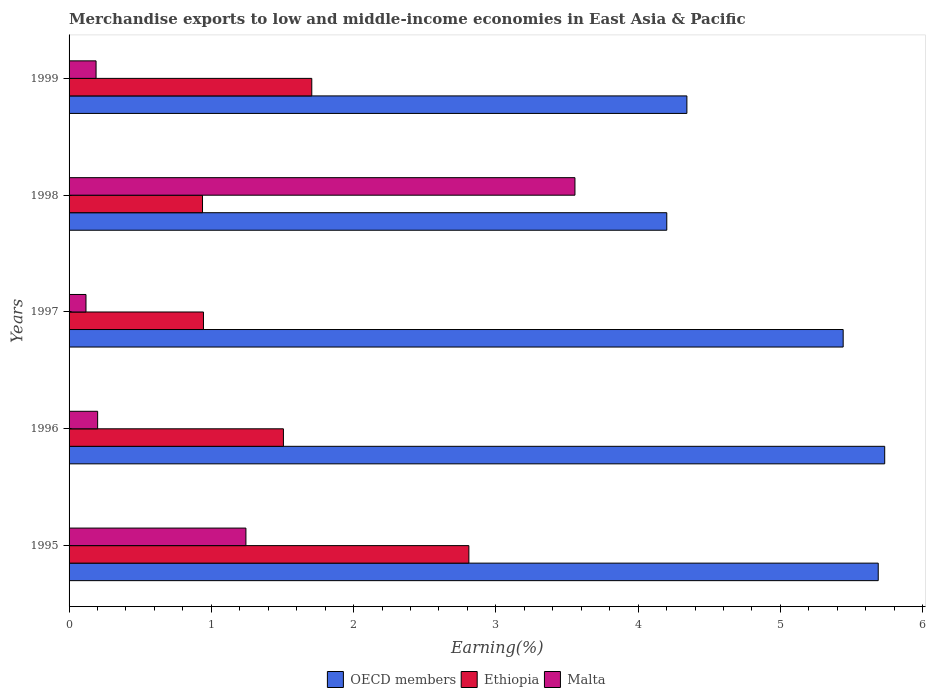How many different coloured bars are there?
Your answer should be compact. 3. How many groups of bars are there?
Offer a very short reply. 5. Are the number of bars per tick equal to the number of legend labels?
Offer a very short reply. Yes. How many bars are there on the 5th tick from the top?
Your answer should be compact. 3. How many bars are there on the 5th tick from the bottom?
Provide a succinct answer. 3. What is the label of the 4th group of bars from the top?
Your response must be concise. 1996. In how many cases, is the number of bars for a given year not equal to the number of legend labels?
Give a very brief answer. 0. What is the percentage of amount earned from merchandise exports in OECD members in 1998?
Your answer should be very brief. 4.2. Across all years, what is the maximum percentage of amount earned from merchandise exports in Ethiopia?
Offer a very short reply. 2.81. Across all years, what is the minimum percentage of amount earned from merchandise exports in Malta?
Your answer should be very brief. 0.12. In which year was the percentage of amount earned from merchandise exports in Malta maximum?
Offer a very short reply. 1998. In which year was the percentage of amount earned from merchandise exports in Ethiopia minimum?
Offer a terse response. 1998. What is the total percentage of amount earned from merchandise exports in Malta in the graph?
Give a very brief answer. 5.31. What is the difference between the percentage of amount earned from merchandise exports in Malta in 1995 and that in 1998?
Ensure brevity in your answer.  -2.31. What is the difference between the percentage of amount earned from merchandise exports in Ethiopia in 1998 and the percentage of amount earned from merchandise exports in OECD members in 1997?
Your response must be concise. -4.5. What is the average percentage of amount earned from merchandise exports in Malta per year?
Ensure brevity in your answer.  1.06. In the year 1996, what is the difference between the percentage of amount earned from merchandise exports in Ethiopia and percentage of amount earned from merchandise exports in Malta?
Your answer should be compact. 1.31. What is the ratio of the percentage of amount earned from merchandise exports in Malta in 1995 to that in 1998?
Provide a short and direct response. 0.35. Is the difference between the percentage of amount earned from merchandise exports in Ethiopia in 1995 and 1998 greater than the difference between the percentage of amount earned from merchandise exports in Malta in 1995 and 1998?
Your answer should be compact. Yes. What is the difference between the highest and the second highest percentage of amount earned from merchandise exports in Ethiopia?
Ensure brevity in your answer.  1.1. What is the difference between the highest and the lowest percentage of amount earned from merchandise exports in Ethiopia?
Ensure brevity in your answer.  1.87. In how many years, is the percentage of amount earned from merchandise exports in Ethiopia greater than the average percentage of amount earned from merchandise exports in Ethiopia taken over all years?
Your answer should be compact. 2. Is the sum of the percentage of amount earned from merchandise exports in Ethiopia in 1996 and 1999 greater than the maximum percentage of amount earned from merchandise exports in Malta across all years?
Provide a succinct answer. No. What does the 1st bar from the top in 1998 represents?
Keep it short and to the point. Malta. Is it the case that in every year, the sum of the percentage of amount earned from merchandise exports in Ethiopia and percentage of amount earned from merchandise exports in Malta is greater than the percentage of amount earned from merchandise exports in OECD members?
Offer a very short reply. No. Are all the bars in the graph horizontal?
Provide a succinct answer. Yes. How many years are there in the graph?
Make the answer very short. 5. Does the graph contain any zero values?
Provide a short and direct response. No. Where does the legend appear in the graph?
Offer a terse response. Bottom center. How many legend labels are there?
Offer a terse response. 3. What is the title of the graph?
Make the answer very short. Merchandise exports to low and middle-income economies in East Asia & Pacific. What is the label or title of the X-axis?
Your response must be concise. Earning(%). What is the Earning(%) of OECD members in 1995?
Provide a short and direct response. 5.69. What is the Earning(%) of Ethiopia in 1995?
Provide a succinct answer. 2.81. What is the Earning(%) in Malta in 1995?
Keep it short and to the point. 1.24. What is the Earning(%) in OECD members in 1996?
Provide a short and direct response. 5.73. What is the Earning(%) of Ethiopia in 1996?
Offer a very short reply. 1.51. What is the Earning(%) of Malta in 1996?
Keep it short and to the point. 0.2. What is the Earning(%) in OECD members in 1997?
Offer a terse response. 5.44. What is the Earning(%) of Ethiopia in 1997?
Your answer should be very brief. 0.94. What is the Earning(%) of Malta in 1997?
Give a very brief answer. 0.12. What is the Earning(%) of OECD members in 1998?
Make the answer very short. 4.2. What is the Earning(%) in Ethiopia in 1998?
Offer a very short reply. 0.94. What is the Earning(%) of Malta in 1998?
Provide a succinct answer. 3.56. What is the Earning(%) in OECD members in 1999?
Offer a terse response. 4.34. What is the Earning(%) in Ethiopia in 1999?
Make the answer very short. 1.71. What is the Earning(%) in Malta in 1999?
Offer a very short reply. 0.19. Across all years, what is the maximum Earning(%) of OECD members?
Your answer should be very brief. 5.73. Across all years, what is the maximum Earning(%) in Ethiopia?
Your answer should be very brief. 2.81. Across all years, what is the maximum Earning(%) of Malta?
Make the answer very short. 3.56. Across all years, what is the minimum Earning(%) in OECD members?
Offer a very short reply. 4.2. Across all years, what is the minimum Earning(%) of Ethiopia?
Your response must be concise. 0.94. Across all years, what is the minimum Earning(%) of Malta?
Your response must be concise. 0.12. What is the total Earning(%) in OECD members in the graph?
Your answer should be very brief. 25.41. What is the total Earning(%) of Ethiopia in the graph?
Offer a terse response. 7.91. What is the total Earning(%) in Malta in the graph?
Offer a terse response. 5.31. What is the difference between the Earning(%) of OECD members in 1995 and that in 1996?
Keep it short and to the point. -0.05. What is the difference between the Earning(%) in Ethiopia in 1995 and that in 1996?
Give a very brief answer. 1.3. What is the difference between the Earning(%) of Malta in 1995 and that in 1996?
Ensure brevity in your answer.  1.04. What is the difference between the Earning(%) of OECD members in 1995 and that in 1997?
Offer a very short reply. 0.25. What is the difference between the Earning(%) of Ethiopia in 1995 and that in 1997?
Provide a succinct answer. 1.87. What is the difference between the Earning(%) of Malta in 1995 and that in 1997?
Your answer should be compact. 1.12. What is the difference between the Earning(%) in OECD members in 1995 and that in 1998?
Your answer should be very brief. 1.49. What is the difference between the Earning(%) in Ethiopia in 1995 and that in 1998?
Your answer should be compact. 1.87. What is the difference between the Earning(%) of Malta in 1995 and that in 1998?
Make the answer very short. -2.31. What is the difference between the Earning(%) of OECD members in 1995 and that in 1999?
Make the answer very short. 1.34. What is the difference between the Earning(%) in Ethiopia in 1995 and that in 1999?
Your answer should be very brief. 1.1. What is the difference between the Earning(%) of Malta in 1995 and that in 1999?
Your answer should be very brief. 1.05. What is the difference between the Earning(%) of OECD members in 1996 and that in 1997?
Offer a very short reply. 0.29. What is the difference between the Earning(%) in Ethiopia in 1996 and that in 1997?
Your answer should be very brief. 0.56. What is the difference between the Earning(%) in Malta in 1996 and that in 1997?
Provide a short and direct response. 0.08. What is the difference between the Earning(%) of OECD members in 1996 and that in 1998?
Give a very brief answer. 1.53. What is the difference between the Earning(%) of Ethiopia in 1996 and that in 1998?
Ensure brevity in your answer.  0.57. What is the difference between the Earning(%) in Malta in 1996 and that in 1998?
Give a very brief answer. -3.36. What is the difference between the Earning(%) of OECD members in 1996 and that in 1999?
Make the answer very short. 1.39. What is the difference between the Earning(%) in Ethiopia in 1996 and that in 1999?
Give a very brief answer. -0.2. What is the difference between the Earning(%) of Malta in 1996 and that in 1999?
Make the answer very short. 0.01. What is the difference between the Earning(%) in OECD members in 1997 and that in 1998?
Provide a short and direct response. 1.24. What is the difference between the Earning(%) in Ethiopia in 1997 and that in 1998?
Your answer should be compact. 0.01. What is the difference between the Earning(%) of Malta in 1997 and that in 1998?
Make the answer very short. -3.44. What is the difference between the Earning(%) in OECD members in 1997 and that in 1999?
Ensure brevity in your answer.  1.1. What is the difference between the Earning(%) of Ethiopia in 1997 and that in 1999?
Ensure brevity in your answer.  -0.76. What is the difference between the Earning(%) of Malta in 1997 and that in 1999?
Provide a short and direct response. -0.07. What is the difference between the Earning(%) in OECD members in 1998 and that in 1999?
Your response must be concise. -0.14. What is the difference between the Earning(%) of Ethiopia in 1998 and that in 1999?
Ensure brevity in your answer.  -0.77. What is the difference between the Earning(%) in Malta in 1998 and that in 1999?
Make the answer very short. 3.37. What is the difference between the Earning(%) in OECD members in 1995 and the Earning(%) in Ethiopia in 1996?
Your answer should be compact. 4.18. What is the difference between the Earning(%) of OECD members in 1995 and the Earning(%) of Malta in 1996?
Keep it short and to the point. 5.49. What is the difference between the Earning(%) of Ethiopia in 1995 and the Earning(%) of Malta in 1996?
Provide a succinct answer. 2.61. What is the difference between the Earning(%) in OECD members in 1995 and the Earning(%) in Ethiopia in 1997?
Provide a succinct answer. 4.74. What is the difference between the Earning(%) in OECD members in 1995 and the Earning(%) in Malta in 1997?
Your answer should be very brief. 5.57. What is the difference between the Earning(%) in Ethiopia in 1995 and the Earning(%) in Malta in 1997?
Your answer should be compact. 2.69. What is the difference between the Earning(%) in OECD members in 1995 and the Earning(%) in Ethiopia in 1998?
Offer a very short reply. 4.75. What is the difference between the Earning(%) of OECD members in 1995 and the Earning(%) of Malta in 1998?
Give a very brief answer. 2.13. What is the difference between the Earning(%) in Ethiopia in 1995 and the Earning(%) in Malta in 1998?
Provide a succinct answer. -0.75. What is the difference between the Earning(%) in OECD members in 1995 and the Earning(%) in Ethiopia in 1999?
Provide a short and direct response. 3.98. What is the difference between the Earning(%) of OECD members in 1995 and the Earning(%) of Malta in 1999?
Give a very brief answer. 5.5. What is the difference between the Earning(%) of Ethiopia in 1995 and the Earning(%) of Malta in 1999?
Your response must be concise. 2.62. What is the difference between the Earning(%) in OECD members in 1996 and the Earning(%) in Ethiopia in 1997?
Your answer should be compact. 4.79. What is the difference between the Earning(%) of OECD members in 1996 and the Earning(%) of Malta in 1997?
Provide a succinct answer. 5.61. What is the difference between the Earning(%) of Ethiopia in 1996 and the Earning(%) of Malta in 1997?
Your answer should be compact. 1.39. What is the difference between the Earning(%) in OECD members in 1996 and the Earning(%) in Ethiopia in 1998?
Your response must be concise. 4.8. What is the difference between the Earning(%) of OECD members in 1996 and the Earning(%) of Malta in 1998?
Give a very brief answer. 2.18. What is the difference between the Earning(%) in Ethiopia in 1996 and the Earning(%) in Malta in 1998?
Offer a terse response. -2.05. What is the difference between the Earning(%) of OECD members in 1996 and the Earning(%) of Ethiopia in 1999?
Provide a short and direct response. 4.03. What is the difference between the Earning(%) of OECD members in 1996 and the Earning(%) of Malta in 1999?
Provide a succinct answer. 5.54. What is the difference between the Earning(%) of Ethiopia in 1996 and the Earning(%) of Malta in 1999?
Your answer should be very brief. 1.32. What is the difference between the Earning(%) of OECD members in 1997 and the Earning(%) of Ethiopia in 1998?
Keep it short and to the point. 4.5. What is the difference between the Earning(%) in OECD members in 1997 and the Earning(%) in Malta in 1998?
Give a very brief answer. 1.89. What is the difference between the Earning(%) in Ethiopia in 1997 and the Earning(%) in Malta in 1998?
Give a very brief answer. -2.61. What is the difference between the Earning(%) in OECD members in 1997 and the Earning(%) in Ethiopia in 1999?
Your answer should be very brief. 3.74. What is the difference between the Earning(%) in OECD members in 1997 and the Earning(%) in Malta in 1999?
Offer a very short reply. 5.25. What is the difference between the Earning(%) in Ethiopia in 1997 and the Earning(%) in Malta in 1999?
Provide a short and direct response. 0.75. What is the difference between the Earning(%) of OECD members in 1998 and the Earning(%) of Ethiopia in 1999?
Provide a succinct answer. 2.5. What is the difference between the Earning(%) of OECD members in 1998 and the Earning(%) of Malta in 1999?
Offer a terse response. 4.01. What is the difference between the Earning(%) of Ethiopia in 1998 and the Earning(%) of Malta in 1999?
Offer a very short reply. 0.75. What is the average Earning(%) of OECD members per year?
Your answer should be compact. 5.08. What is the average Earning(%) of Ethiopia per year?
Ensure brevity in your answer.  1.58. What is the average Earning(%) in Malta per year?
Your response must be concise. 1.06. In the year 1995, what is the difference between the Earning(%) of OECD members and Earning(%) of Ethiopia?
Offer a very short reply. 2.88. In the year 1995, what is the difference between the Earning(%) in OECD members and Earning(%) in Malta?
Your answer should be compact. 4.44. In the year 1995, what is the difference between the Earning(%) of Ethiopia and Earning(%) of Malta?
Provide a succinct answer. 1.57. In the year 1996, what is the difference between the Earning(%) in OECD members and Earning(%) in Ethiopia?
Offer a very short reply. 4.23. In the year 1996, what is the difference between the Earning(%) in OECD members and Earning(%) in Malta?
Give a very brief answer. 5.53. In the year 1996, what is the difference between the Earning(%) in Ethiopia and Earning(%) in Malta?
Offer a very short reply. 1.31. In the year 1997, what is the difference between the Earning(%) of OECD members and Earning(%) of Ethiopia?
Ensure brevity in your answer.  4.5. In the year 1997, what is the difference between the Earning(%) in OECD members and Earning(%) in Malta?
Your response must be concise. 5.32. In the year 1997, what is the difference between the Earning(%) in Ethiopia and Earning(%) in Malta?
Your response must be concise. 0.83. In the year 1998, what is the difference between the Earning(%) in OECD members and Earning(%) in Ethiopia?
Make the answer very short. 3.26. In the year 1998, what is the difference between the Earning(%) of OECD members and Earning(%) of Malta?
Ensure brevity in your answer.  0.65. In the year 1998, what is the difference between the Earning(%) in Ethiopia and Earning(%) in Malta?
Offer a terse response. -2.62. In the year 1999, what is the difference between the Earning(%) of OECD members and Earning(%) of Ethiopia?
Provide a succinct answer. 2.64. In the year 1999, what is the difference between the Earning(%) in OECD members and Earning(%) in Malta?
Ensure brevity in your answer.  4.15. In the year 1999, what is the difference between the Earning(%) in Ethiopia and Earning(%) in Malta?
Provide a short and direct response. 1.52. What is the ratio of the Earning(%) of OECD members in 1995 to that in 1996?
Provide a short and direct response. 0.99. What is the ratio of the Earning(%) in Ethiopia in 1995 to that in 1996?
Keep it short and to the point. 1.87. What is the ratio of the Earning(%) in Malta in 1995 to that in 1996?
Provide a short and direct response. 6.19. What is the ratio of the Earning(%) of OECD members in 1995 to that in 1997?
Provide a succinct answer. 1.05. What is the ratio of the Earning(%) in Ethiopia in 1995 to that in 1997?
Give a very brief answer. 2.97. What is the ratio of the Earning(%) in Malta in 1995 to that in 1997?
Give a very brief answer. 10.46. What is the ratio of the Earning(%) in OECD members in 1995 to that in 1998?
Make the answer very short. 1.35. What is the ratio of the Earning(%) of Ethiopia in 1995 to that in 1998?
Keep it short and to the point. 3. What is the ratio of the Earning(%) in Malta in 1995 to that in 1998?
Provide a short and direct response. 0.35. What is the ratio of the Earning(%) of OECD members in 1995 to that in 1999?
Your answer should be very brief. 1.31. What is the ratio of the Earning(%) of Ethiopia in 1995 to that in 1999?
Provide a short and direct response. 1.65. What is the ratio of the Earning(%) in Malta in 1995 to that in 1999?
Keep it short and to the point. 6.55. What is the ratio of the Earning(%) of OECD members in 1996 to that in 1997?
Ensure brevity in your answer.  1.05. What is the ratio of the Earning(%) in Ethiopia in 1996 to that in 1997?
Offer a very short reply. 1.59. What is the ratio of the Earning(%) of Malta in 1996 to that in 1997?
Offer a terse response. 1.69. What is the ratio of the Earning(%) of OECD members in 1996 to that in 1998?
Your response must be concise. 1.36. What is the ratio of the Earning(%) of Ethiopia in 1996 to that in 1998?
Keep it short and to the point. 1.61. What is the ratio of the Earning(%) of Malta in 1996 to that in 1998?
Give a very brief answer. 0.06. What is the ratio of the Earning(%) in OECD members in 1996 to that in 1999?
Provide a succinct answer. 1.32. What is the ratio of the Earning(%) in Ethiopia in 1996 to that in 1999?
Give a very brief answer. 0.88. What is the ratio of the Earning(%) of Malta in 1996 to that in 1999?
Offer a very short reply. 1.06. What is the ratio of the Earning(%) of OECD members in 1997 to that in 1998?
Provide a succinct answer. 1.3. What is the ratio of the Earning(%) of Malta in 1997 to that in 1998?
Your answer should be compact. 0.03. What is the ratio of the Earning(%) in OECD members in 1997 to that in 1999?
Your answer should be very brief. 1.25. What is the ratio of the Earning(%) of Ethiopia in 1997 to that in 1999?
Keep it short and to the point. 0.55. What is the ratio of the Earning(%) of Malta in 1997 to that in 1999?
Your response must be concise. 0.63. What is the ratio of the Earning(%) in OECD members in 1998 to that in 1999?
Your answer should be very brief. 0.97. What is the ratio of the Earning(%) of Ethiopia in 1998 to that in 1999?
Keep it short and to the point. 0.55. What is the ratio of the Earning(%) in Malta in 1998 to that in 1999?
Provide a short and direct response. 18.74. What is the difference between the highest and the second highest Earning(%) in OECD members?
Offer a very short reply. 0.05. What is the difference between the highest and the second highest Earning(%) of Ethiopia?
Provide a succinct answer. 1.1. What is the difference between the highest and the second highest Earning(%) in Malta?
Make the answer very short. 2.31. What is the difference between the highest and the lowest Earning(%) in OECD members?
Ensure brevity in your answer.  1.53. What is the difference between the highest and the lowest Earning(%) in Ethiopia?
Give a very brief answer. 1.87. What is the difference between the highest and the lowest Earning(%) in Malta?
Give a very brief answer. 3.44. 